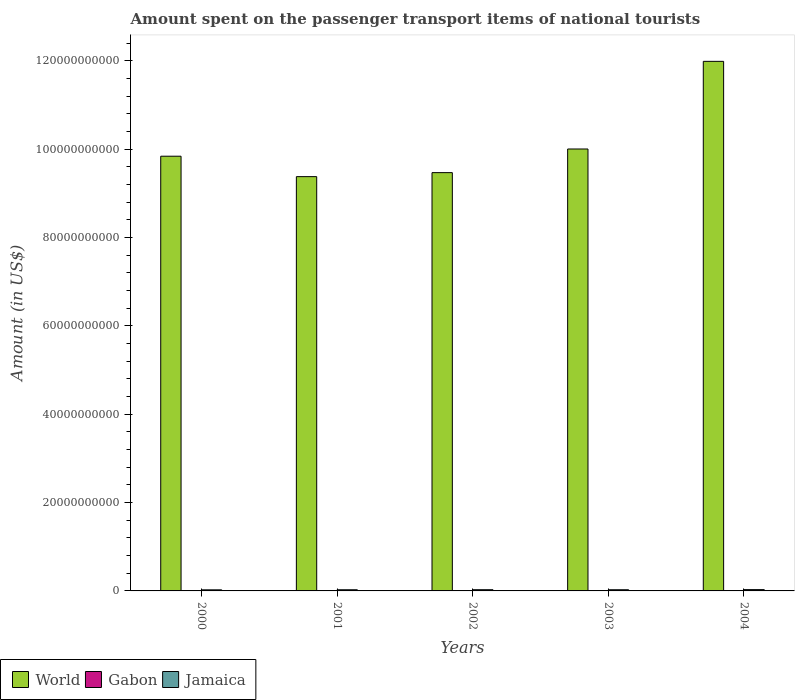Are the number of bars on each tick of the X-axis equal?
Offer a terse response. Yes. How many bars are there on the 4th tick from the right?
Make the answer very short. 3. What is the amount spent on the passenger transport items of national tourists in Jamaica in 2004?
Keep it short and to the point. 2.95e+08. Across all years, what is the maximum amount spent on the passenger transport items of national tourists in Gabon?
Offer a terse response. 7.90e+07. Across all years, what is the minimum amount spent on the passenger transport items of national tourists in Jamaica?
Offer a very short reply. 2.44e+08. In which year was the amount spent on the passenger transport items of national tourists in World minimum?
Offer a terse response. 2001. What is the total amount spent on the passenger transport items of national tourists in Jamaica in the graph?
Offer a very short reply. 1.34e+09. What is the difference between the amount spent on the passenger transport items of national tourists in Gabon in 2002 and that in 2004?
Your response must be concise. -5.00e+06. What is the difference between the amount spent on the passenger transport items of national tourists in Gabon in 2001 and the amount spent on the passenger transport items of national tourists in Jamaica in 2002?
Your answer should be very brief. -2.42e+08. What is the average amount spent on the passenger transport items of national tourists in Gabon per year?
Keep it short and to the point. 6.04e+07. In the year 2001, what is the difference between the amount spent on the passenger transport items of national tourists in Gabon and amount spent on the passenger transport items of national tourists in World?
Keep it short and to the point. -9.38e+1. What is the ratio of the amount spent on the passenger transport items of national tourists in World in 2000 to that in 2002?
Your answer should be compact. 1.04. Is the difference between the amount spent on the passenger transport items of national tourists in Gabon in 2002 and 2003 greater than the difference between the amount spent on the passenger transport items of national tourists in World in 2002 and 2003?
Offer a very short reply. Yes. What is the difference between the highest and the second highest amount spent on the passenger transport items of national tourists in World?
Make the answer very short. 1.98e+1. What is the difference between the highest and the lowest amount spent on the passenger transport items of national tourists in World?
Offer a terse response. 2.61e+1. What does the 3rd bar from the left in 2000 represents?
Provide a short and direct response. Jamaica. What does the 3rd bar from the right in 2004 represents?
Your answer should be very brief. World. Is it the case that in every year, the sum of the amount spent on the passenger transport items of national tourists in World and amount spent on the passenger transport items of national tourists in Jamaica is greater than the amount spent on the passenger transport items of national tourists in Gabon?
Your answer should be very brief. Yes. Are all the bars in the graph horizontal?
Make the answer very short. No. Does the graph contain any zero values?
Make the answer very short. No. Where does the legend appear in the graph?
Give a very brief answer. Bottom left. What is the title of the graph?
Provide a succinct answer. Amount spent on the passenger transport items of national tourists. What is the label or title of the X-axis?
Make the answer very short. Years. What is the label or title of the Y-axis?
Give a very brief answer. Amount (in US$). What is the Amount (in US$) in World in 2000?
Make the answer very short. 9.84e+1. What is the Amount (in US$) in Gabon in 2000?
Your response must be concise. 7.90e+07. What is the Amount (in US$) in Jamaica in 2000?
Give a very brief answer. 2.44e+08. What is the Amount (in US$) of World in 2001?
Make the answer very short. 9.38e+1. What is the Amount (in US$) in Gabon in 2001?
Your answer should be compact. 3.10e+07. What is the Amount (in US$) of Jamaica in 2001?
Give a very brief answer. 2.62e+08. What is the Amount (in US$) in World in 2002?
Ensure brevity in your answer.  9.47e+1. What is the Amount (in US$) in Gabon in 2002?
Make the answer very short. 5.90e+07. What is the Amount (in US$) in Jamaica in 2002?
Your answer should be very brief. 2.73e+08. What is the Amount (in US$) in World in 2003?
Offer a very short reply. 1.00e+11. What is the Amount (in US$) in Gabon in 2003?
Provide a short and direct response. 6.90e+07. What is the Amount (in US$) in Jamaica in 2003?
Provide a short and direct response. 2.66e+08. What is the Amount (in US$) of World in 2004?
Your response must be concise. 1.20e+11. What is the Amount (in US$) in Gabon in 2004?
Your answer should be compact. 6.40e+07. What is the Amount (in US$) in Jamaica in 2004?
Provide a short and direct response. 2.95e+08. Across all years, what is the maximum Amount (in US$) in World?
Your response must be concise. 1.20e+11. Across all years, what is the maximum Amount (in US$) in Gabon?
Keep it short and to the point. 7.90e+07. Across all years, what is the maximum Amount (in US$) of Jamaica?
Provide a short and direct response. 2.95e+08. Across all years, what is the minimum Amount (in US$) of World?
Your answer should be very brief. 9.38e+1. Across all years, what is the minimum Amount (in US$) in Gabon?
Your answer should be very brief. 3.10e+07. Across all years, what is the minimum Amount (in US$) in Jamaica?
Offer a very short reply. 2.44e+08. What is the total Amount (in US$) in World in the graph?
Give a very brief answer. 5.07e+11. What is the total Amount (in US$) of Gabon in the graph?
Your answer should be very brief. 3.02e+08. What is the total Amount (in US$) in Jamaica in the graph?
Offer a very short reply. 1.34e+09. What is the difference between the Amount (in US$) of World in 2000 and that in 2001?
Your response must be concise. 4.62e+09. What is the difference between the Amount (in US$) in Gabon in 2000 and that in 2001?
Keep it short and to the point. 4.80e+07. What is the difference between the Amount (in US$) of Jamaica in 2000 and that in 2001?
Your answer should be compact. -1.80e+07. What is the difference between the Amount (in US$) of World in 2000 and that in 2002?
Offer a very short reply. 3.72e+09. What is the difference between the Amount (in US$) of Gabon in 2000 and that in 2002?
Offer a very short reply. 2.00e+07. What is the difference between the Amount (in US$) in Jamaica in 2000 and that in 2002?
Provide a succinct answer. -2.90e+07. What is the difference between the Amount (in US$) in World in 2000 and that in 2003?
Your answer should be compact. -1.63e+09. What is the difference between the Amount (in US$) in Jamaica in 2000 and that in 2003?
Make the answer very short. -2.20e+07. What is the difference between the Amount (in US$) of World in 2000 and that in 2004?
Your answer should be compact. -2.15e+1. What is the difference between the Amount (in US$) in Gabon in 2000 and that in 2004?
Your answer should be compact. 1.50e+07. What is the difference between the Amount (in US$) of Jamaica in 2000 and that in 2004?
Give a very brief answer. -5.10e+07. What is the difference between the Amount (in US$) in World in 2001 and that in 2002?
Your response must be concise. -9.04e+08. What is the difference between the Amount (in US$) in Gabon in 2001 and that in 2002?
Offer a terse response. -2.80e+07. What is the difference between the Amount (in US$) in Jamaica in 2001 and that in 2002?
Your response must be concise. -1.10e+07. What is the difference between the Amount (in US$) in World in 2001 and that in 2003?
Offer a very short reply. -6.26e+09. What is the difference between the Amount (in US$) of Gabon in 2001 and that in 2003?
Ensure brevity in your answer.  -3.80e+07. What is the difference between the Amount (in US$) in Jamaica in 2001 and that in 2003?
Your response must be concise. -4.00e+06. What is the difference between the Amount (in US$) in World in 2001 and that in 2004?
Make the answer very short. -2.61e+1. What is the difference between the Amount (in US$) of Gabon in 2001 and that in 2004?
Give a very brief answer. -3.30e+07. What is the difference between the Amount (in US$) of Jamaica in 2001 and that in 2004?
Your answer should be compact. -3.30e+07. What is the difference between the Amount (in US$) in World in 2002 and that in 2003?
Offer a very short reply. -5.35e+09. What is the difference between the Amount (in US$) of Gabon in 2002 and that in 2003?
Your answer should be compact. -1.00e+07. What is the difference between the Amount (in US$) in Jamaica in 2002 and that in 2003?
Offer a very short reply. 7.00e+06. What is the difference between the Amount (in US$) in World in 2002 and that in 2004?
Ensure brevity in your answer.  -2.52e+1. What is the difference between the Amount (in US$) of Gabon in 2002 and that in 2004?
Keep it short and to the point. -5.00e+06. What is the difference between the Amount (in US$) of Jamaica in 2002 and that in 2004?
Keep it short and to the point. -2.20e+07. What is the difference between the Amount (in US$) in World in 2003 and that in 2004?
Provide a succinct answer. -1.98e+1. What is the difference between the Amount (in US$) of Jamaica in 2003 and that in 2004?
Provide a short and direct response. -2.90e+07. What is the difference between the Amount (in US$) in World in 2000 and the Amount (in US$) in Gabon in 2001?
Offer a very short reply. 9.84e+1. What is the difference between the Amount (in US$) of World in 2000 and the Amount (in US$) of Jamaica in 2001?
Offer a very short reply. 9.82e+1. What is the difference between the Amount (in US$) in Gabon in 2000 and the Amount (in US$) in Jamaica in 2001?
Ensure brevity in your answer.  -1.83e+08. What is the difference between the Amount (in US$) of World in 2000 and the Amount (in US$) of Gabon in 2002?
Provide a short and direct response. 9.84e+1. What is the difference between the Amount (in US$) of World in 2000 and the Amount (in US$) of Jamaica in 2002?
Provide a short and direct response. 9.82e+1. What is the difference between the Amount (in US$) in Gabon in 2000 and the Amount (in US$) in Jamaica in 2002?
Ensure brevity in your answer.  -1.94e+08. What is the difference between the Amount (in US$) in World in 2000 and the Amount (in US$) in Gabon in 2003?
Offer a very short reply. 9.84e+1. What is the difference between the Amount (in US$) of World in 2000 and the Amount (in US$) of Jamaica in 2003?
Keep it short and to the point. 9.82e+1. What is the difference between the Amount (in US$) of Gabon in 2000 and the Amount (in US$) of Jamaica in 2003?
Your response must be concise. -1.87e+08. What is the difference between the Amount (in US$) in World in 2000 and the Amount (in US$) in Gabon in 2004?
Offer a very short reply. 9.84e+1. What is the difference between the Amount (in US$) of World in 2000 and the Amount (in US$) of Jamaica in 2004?
Your answer should be compact. 9.81e+1. What is the difference between the Amount (in US$) of Gabon in 2000 and the Amount (in US$) of Jamaica in 2004?
Keep it short and to the point. -2.16e+08. What is the difference between the Amount (in US$) of World in 2001 and the Amount (in US$) of Gabon in 2002?
Provide a succinct answer. 9.38e+1. What is the difference between the Amount (in US$) in World in 2001 and the Amount (in US$) in Jamaica in 2002?
Your response must be concise. 9.35e+1. What is the difference between the Amount (in US$) of Gabon in 2001 and the Amount (in US$) of Jamaica in 2002?
Your answer should be very brief. -2.42e+08. What is the difference between the Amount (in US$) in World in 2001 and the Amount (in US$) in Gabon in 2003?
Make the answer very short. 9.37e+1. What is the difference between the Amount (in US$) in World in 2001 and the Amount (in US$) in Jamaica in 2003?
Ensure brevity in your answer.  9.35e+1. What is the difference between the Amount (in US$) in Gabon in 2001 and the Amount (in US$) in Jamaica in 2003?
Provide a succinct answer. -2.35e+08. What is the difference between the Amount (in US$) of World in 2001 and the Amount (in US$) of Gabon in 2004?
Offer a very short reply. 9.37e+1. What is the difference between the Amount (in US$) in World in 2001 and the Amount (in US$) in Jamaica in 2004?
Provide a succinct answer. 9.35e+1. What is the difference between the Amount (in US$) in Gabon in 2001 and the Amount (in US$) in Jamaica in 2004?
Your answer should be very brief. -2.64e+08. What is the difference between the Amount (in US$) in World in 2002 and the Amount (in US$) in Gabon in 2003?
Your response must be concise. 9.46e+1. What is the difference between the Amount (in US$) in World in 2002 and the Amount (in US$) in Jamaica in 2003?
Your answer should be compact. 9.44e+1. What is the difference between the Amount (in US$) of Gabon in 2002 and the Amount (in US$) of Jamaica in 2003?
Your response must be concise. -2.07e+08. What is the difference between the Amount (in US$) of World in 2002 and the Amount (in US$) of Gabon in 2004?
Your response must be concise. 9.47e+1. What is the difference between the Amount (in US$) of World in 2002 and the Amount (in US$) of Jamaica in 2004?
Your answer should be very brief. 9.44e+1. What is the difference between the Amount (in US$) in Gabon in 2002 and the Amount (in US$) in Jamaica in 2004?
Provide a succinct answer. -2.36e+08. What is the difference between the Amount (in US$) in World in 2003 and the Amount (in US$) in Gabon in 2004?
Give a very brief answer. 1.00e+11. What is the difference between the Amount (in US$) of World in 2003 and the Amount (in US$) of Jamaica in 2004?
Make the answer very short. 9.98e+1. What is the difference between the Amount (in US$) in Gabon in 2003 and the Amount (in US$) in Jamaica in 2004?
Your answer should be very brief. -2.26e+08. What is the average Amount (in US$) of World per year?
Offer a terse response. 1.01e+11. What is the average Amount (in US$) in Gabon per year?
Your answer should be compact. 6.04e+07. What is the average Amount (in US$) in Jamaica per year?
Give a very brief answer. 2.68e+08. In the year 2000, what is the difference between the Amount (in US$) of World and Amount (in US$) of Gabon?
Your response must be concise. 9.84e+1. In the year 2000, what is the difference between the Amount (in US$) in World and Amount (in US$) in Jamaica?
Your answer should be very brief. 9.82e+1. In the year 2000, what is the difference between the Amount (in US$) in Gabon and Amount (in US$) in Jamaica?
Offer a very short reply. -1.65e+08. In the year 2001, what is the difference between the Amount (in US$) in World and Amount (in US$) in Gabon?
Keep it short and to the point. 9.38e+1. In the year 2001, what is the difference between the Amount (in US$) of World and Amount (in US$) of Jamaica?
Your answer should be very brief. 9.35e+1. In the year 2001, what is the difference between the Amount (in US$) of Gabon and Amount (in US$) of Jamaica?
Provide a short and direct response. -2.31e+08. In the year 2002, what is the difference between the Amount (in US$) in World and Amount (in US$) in Gabon?
Offer a terse response. 9.47e+1. In the year 2002, what is the difference between the Amount (in US$) in World and Amount (in US$) in Jamaica?
Provide a short and direct response. 9.44e+1. In the year 2002, what is the difference between the Amount (in US$) in Gabon and Amount (in US$) in Jamaica?
Your answer should be very brief. -2.14e+08. In the year 2003, what is the difference between the Amount (in US$) of World and Amount (in US$) of Gabon?
Provide a short and direct response. 1.00e+11. In the year 2003, what is the difference between the Amount (in US$) in World and Amount (in US$) in Jamaica?
Make the answer very short. 9.98e+1. In the year 2003, what is the difference between the Amount (in US$) in Gabon and Amount (in US$) in Jamaica?
Your answer should be compact. -1.97e+08. In the year 2004, what is the difference between the Amount (in US$) of World and Amount (in US$) of Gabon?
Offer a terse response. 1.20e+11. In the year 2004, what is the difference between the Amount (in US$) in World and Amount (in US$) in Jamaica?
Provide a succinct answer. 1.20e+11. In the year 2004, what is the difference between the Amount (in US$) of Gabon and Amount (in US$) of Jamaica?
Give a very brief answer. -2.31e+08. What is the ratio of the Amount (in US$) of World in 2000 to that in 2001?
Offer a terse response. 1.05. What is the ratio of the Amount (in US$) of Gabon in 2000 to that in 2001?
Give a very brief answer. 2.55. What is the ratio of the Amount (in US$) in Jamaica in 2000 to that in 2001?
Provide a succinct answer. 0.93. What is the ratio of the Amount (in US$) in World in 2000 to that in 2002?
Give a very brief answer. 1.04. What is the ratio of the Amount (in US$) of Gabon in 2000 to that in 2002?
Your answer should be very brief. 1.34. What is the ratio of the Amount (in US$) of Jamaica in 2000 to that in 2002?
Ensure brevity in your answer.  0.89. What is the ratio of the Amount (in US$) of World in 2000 to that in 2003?
Keep it short and to the point. 0.98. What is the ratio of the Amount (in US$) of Gabon in 2000 to that in 2003?
Your response must be concise. 1.14. What is the ratio of the Amount (in US$) of Jamaica in 2000 to that in 2003?
Your answer should be very brief. 0.92. What is the ratio of the Amount (in US$) in World in 2000 to that in 2004?
Your answer should be compact. 0.82. What is the ratio of the Amount (in US$) of Gabon in 2000 to that in 2004?
Offer a terse response. 1.23. What is the ratio of the Amount (in US$) of Jamaica in 2000 to that in 2004?
Give a very brief answer. 0.83. What is the ratio of the Amount (in US$) of Gabon in 2001 to that in 2002?
Make the answer very short. 0.53. What is the ratio of the Amount (in US$) in Jamaica in 2001 to that in 2002?
Offer a terse response. 0.96. What is the ratio of the Amount (in US$) in Gabon in 2001 to that in 2003?
Your answer should be compact. 0.45. What is the ratio of the Amount (in US$) of Jamaica in 2001 to that in 2003?
Provide a short and direct response. 0.98. What is the ratio of the Amount (in US$) in World in 2001 to that in 2004?
Offer a terse response. 0.78. What is the ratio of the Amount (in US$) in Gabon in 2001 to that in 2004?
Make the answer very short. 0.48. What is the ratio of the Amount (in US$) of Jamaica in 2001 to that in 2004?
Ensure brevity in your answer.  0.89. What is the ratio of the Amount (in US$) in World in 2002 to that in 2003?
Make the answer very short. 0.95. What is the ratio of the Amount (in US$) in Gabon in 2002 to that in 2003?
Provide a short and direct response. 0.86. What is the ratio of the Amount (in US$) in Jamaica in 2002 to that in 2003?
Provide a short and direct response. 1.03. What is the ratio of the Amount (in US$) in World in 2002 to that in 2004?
Offer a terse response. 0.79. What is the ratio of the Amount (in US$) in Gabon in 2002 to that in 2004?
Keep it short and to the point. 0.92. What is the ratio of the Amount (in US$) of Jamaica in 2002 to that in 2004?
Make the answer very short. 0.93. What is the ratio of the Amount (in US$) in World in 2003 to that in 2004?
Your answer should be very brief. 0.83. What is the ratio of the Amount (in US$) in Gabon in 2003 to that in 2004?
Give a very brief answer. 1.08. What is the ratio of the Amount (in US$) in Jamaica in 2003 to that in 2004?
Offer a very short reply. 0.9. What is the difference between the highest and the second highest Amount (in US$) in World?
Provide a short and direct response. 1.98e+1. What is the difference between the highest and the second highest Amount (in US$) of Gabon?
Your answer should be compact. 1.00e+07. What is the difference between the highest and the second highest Amount (in US$) in Jamaica?
Make the answer very short. 2.20e+07. What is the difference between the highest and the lowest Amount (in US$) of World?
Provide a short and direct response. 2.61e+1. What is the difference between the highest and the lowest Amount (in US$) in Gabon?
Your answer should be compact. 4.80e+07. What is the difference between the highest and the lowest Amount (in US$) of Jamaica?
Give a very brief answer. 5.10e+07. 